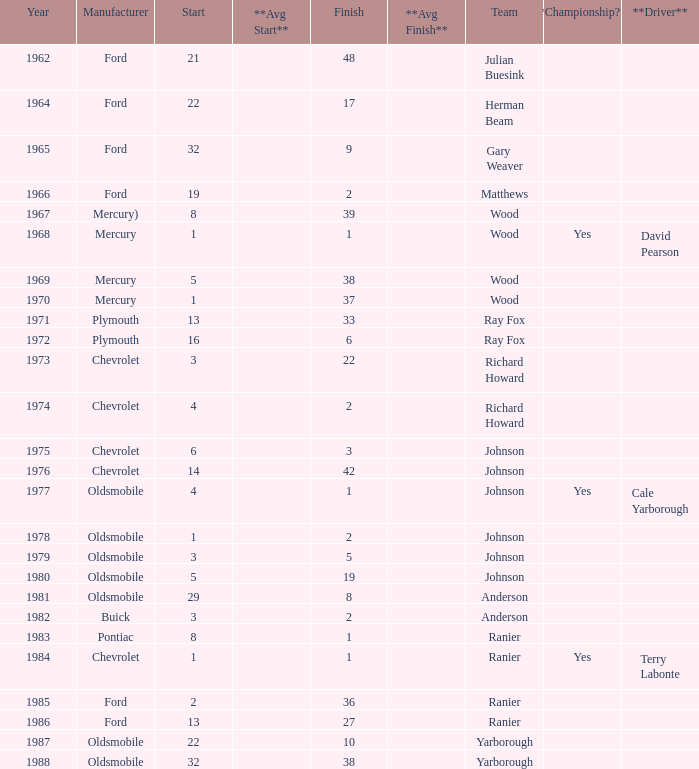What is the smallest finish time for a race after 1972 with a car manufactured by pontiac? 1.0. 